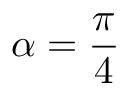<formula> <loc_0><loc_0><loc_500><loc_500>\alpha = \frac { \pi } { 4 }</formula> 